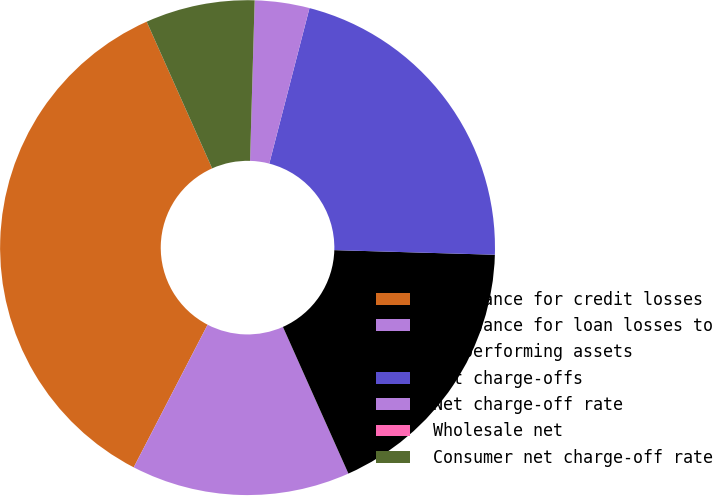Convert chart. <chart><loc_0><loc_0><loc_500><loc_500><pie_chart><fcel>Allowance for credit losses<fcel>Allowance for loan losses to<fcel>Nonperforming assets<fcel>Net charge-offs<fcel>Net charge-off rate<fcel>Wholesale net<fcel>Consumer net charge-off rate<nl><fcel>35.71%<fcel>14.29%<fcel>17.86%<fcel>21.43%<fcel>3.57%<fcel>0.0%<fcel>7.14%<nl></chart> 